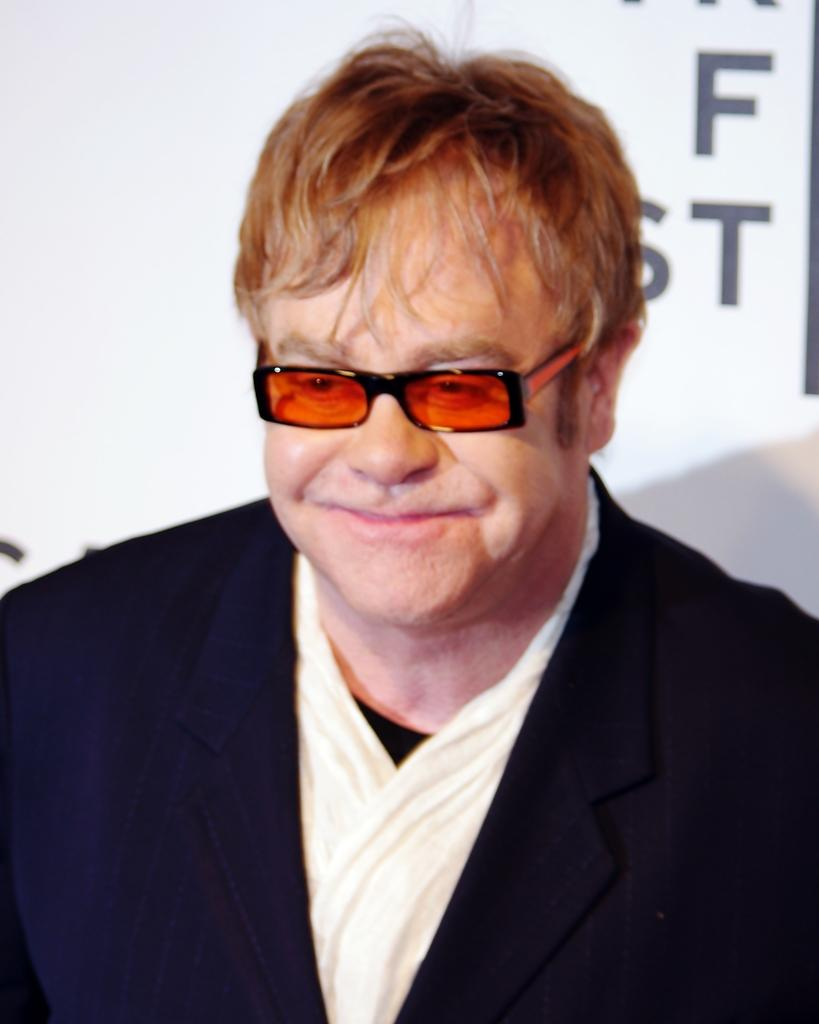What is the main subject of the image? The main subject of the image is a man. What is the man wearing on his face? The man is wearing orange color goggles. What type of clothing is the man wearing on his upper body? The man is wearing a black jacket and a white shirt. What is the man's facial expression in the image? The man is smiling in the image. What can be seen in the background of the image? There is a white poster in the background of the image. What type of carriage can be seen in the image? There is no carriage present in the image. What attraction is the man visiting in the image? The image does not provide information about any specific attraction the man might be visiting. 